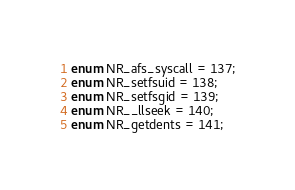<code> <loc_0><loc_0><loc_500><loc_500><_D_>enum NR_afs_syscall = 137;
enum NR_setfsuid = 138;
enum NR_setfsgid = 139;
enum NR__llseek = 140;
enum NR_getdents = 141;</code> 